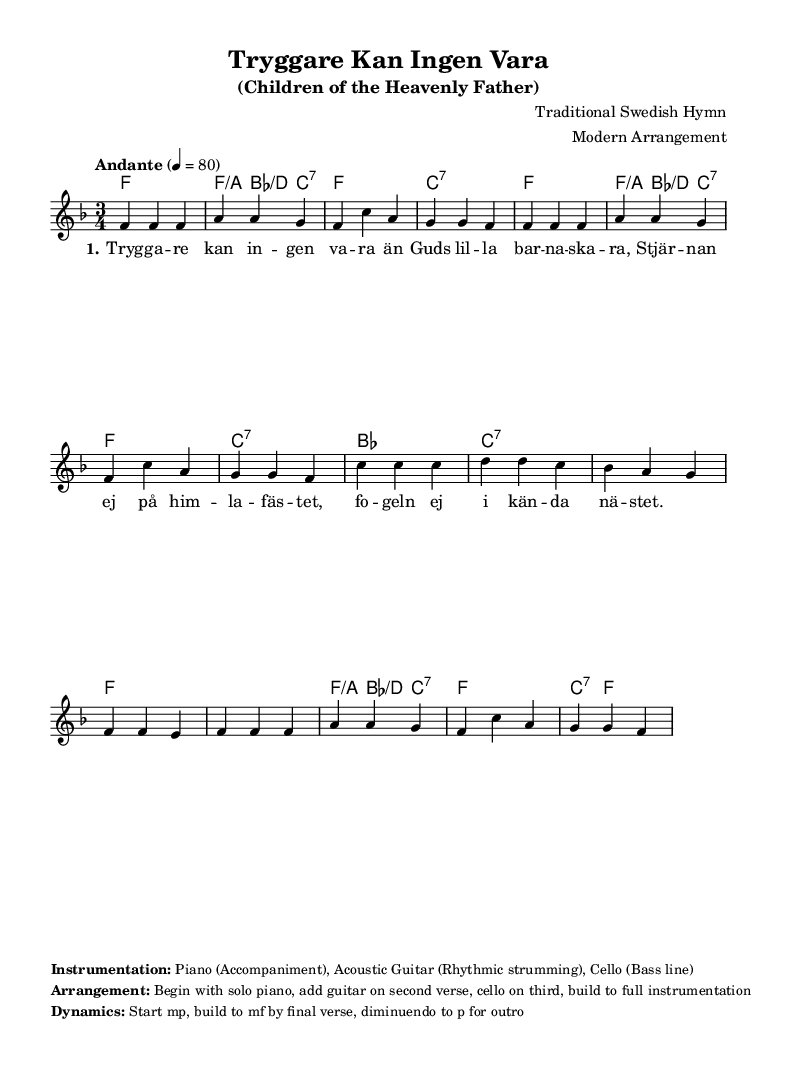What is the key signature of this music? The key signature shows that the piece is in F major, which has one flat (B flat). This can be confirmed by looking for the key signature notations at the beginning of the staff.
Answer: F major What is the time signature of this hymn? The time signature displayed at the beginning of the piece is 3/4, which indicates that there are three beats per measure and the quarter note receives one beat. This can be found in the time signature notation at the beginning.
Answer: 3/4 What is the tempo marking of this arrangement? The tempo marking states "Andante" and indicates a speed of 80 beats per minute. It describes the pace at which the piece should be played, which is also found marked alongside the time signature.
Answer: Andante, 80 How many measures does the melody have in this arrangement? By counting the measures represented in the melody section of the staff, I can see there are a total of eleven measures. This includes all the segments defined by vertical bar lines.
Answer: 11 At what dynamic level does the arrangement begin? The piece specifies to start at mp (mezzo-piano), which indicates a moderately soft dynamic level. This marking can be found in the dynamics section at the start of the sheet music.
Answer: mp What instruments are used in this modern arrangement? The arrangement indicates that the instrumentation includes piano, acoustic guitar, and cello. The specific roles of each instrument are detailed under the instrumentation section in the markup of the code.
Answer: Piano, Acoustic Guitar, Cello What is the last dynamic marking before the outro? The final dynamic marking before the outro instructs to diminuendo to p (piano), indicating a gradual decrease in volume. This instruction is noted at the end of the score dynamics section.
Answer: p 